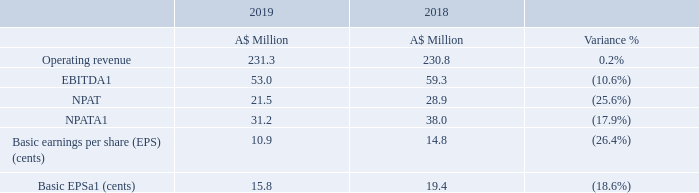Review of operations
The Group’s operating performance for the fiscal year compared to last year is as follows:
1. The Directors believe the information additional to IFRS measures included in the report is relevant and useful in measuring the financial performance of the Group. These include: EBITDA, NPATA and EPSa. These measures have been defined in the Chairperson and Chief Executive Officer’s Joint Report on page 2.
In 2019 the business continued to deliver strong results after the record 2018 year. Revenues and EBITDA were in line with guidance. Further details on the Group’s results are outlined in the Chairperson and Chief Executive Officer’s Joint Report on page 2.
On 1 June 2019, Hansen acquired the Sigma Systems business (Sigma) and one month of these results are included in the FY19 result. Also included in the results are the transaction and other restructuring costs related to the acquisition, which we have identified as separately disclosed items in our results.
This acquisition has also resulted in the re-balancing of the Group’s market portfolio which, post the acquisition of Enoro in FY18, was initially weighted towards the Utilities sector. With Sigma’s revenues concentrated in the Communications sector, the Group’s revenue portfolio is now re-balanced to ensure greater diversification across multiple industries, regions and clients.
The Group has generated operating cash flows of $39.7 million, which has been used to retire external debt and fund dividends of $12.6 million during the financial year. With the introduction of a higher level of debt in June 2019 to fund the Sigma acquisition, the Group has, for the first time, used the strength of the Group’s balance sheet to fund 100% of an acquisition. With the Group’s strong cash generation, Hansen is well placed to service and retire the debt over the coming years.
How much operating cash flows was generated by Hansen Technologies? $39.7 million. Which sector was Sigma's revenue concentrated in? Communications. What was the Operating revenue for 2019?
Answer scale should be: million. 231.3. What was the average difference between EBITDA and NPAT for both FYs?
Answer scale should be: million. ((53.0 - 21.5) + (59.3 - 28.9)) / 2 
Answer: 30.95. What was the average basic EPSa for both FYs? (15.8 + 19.4)/2 
Answer: 17.6. What was the average difference between basic EPS and basic EPSa for both FYs? ((15.8 - 10.9) + (19.4 - 14.8)) / 2 
Answer: 4.75. 